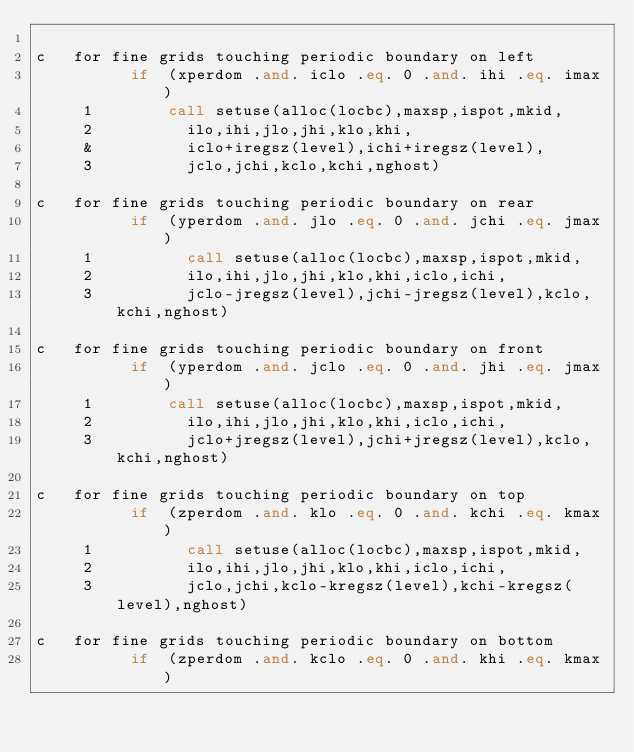Convert code to text. <code><loc_0><loc_0><loc_500><loc_500><_FORTRAN_> 
c   for fine grids touching periodic boundary on left
          if  (xperdom .and. iclo .eq. 0 .and. ihi .eq. imax)
     1        call setuse(alloc(locbc),maxsp,ispot,mkid,
     2          ilo,ihi,jlo,jhi,klo,khi,
     &          iclo+iregsz(level),ichi+iregsz(level),
     3          jclo,jchi,kclo,kchi,nghost)
 
c   for fine grids touching periodic boundary on rear
          if  (yperdom .and. jlo .eq. 0 .and. jchi .eq. jmax)
     1          call setuse(alloc(locbc),maxsp,ispot,mkid,
     2          ilo,ihi,jlo,jhi,klo,khi,iclo,ichi,
     3          jclo-jregsz(level),jchi-jregsz(level),kclo,kchi,nghost)
 
c   for fine grids touching periodic boundary on front
          if  (yperdom .and. jclo .eq. 0 .and. jhi .eq. jmax)
     1        call setuse(alloc(locbc),maxsp,ispot,mkid,
     2          ilo,ihi,jlo,jhi,klo,khi,iclo,ichi,
     3          jclo+jregsz(level),jchi+jregsz(level),kclo,kchi,nghost)
 
c   for fine grids touching periodic boundary on top
          if  (zperdom .and. klo .eq. 0 .and. kchi .eq. kmax)
     1          call setuse(alloc(locbc),maxsp,ispot,mkid,
     2          ilo,ihi,jlo,jhi,klo,khi,iclo,ichi,
     3          jclo,jchi,kclo-kregsz(level),kchi-kregsz(level),nghost)

c   for fine grids touching periodic boundary on bottom
          if  (zperdom .and. kclo .eq. 0 .and. khi .eq. kmax)</code> 